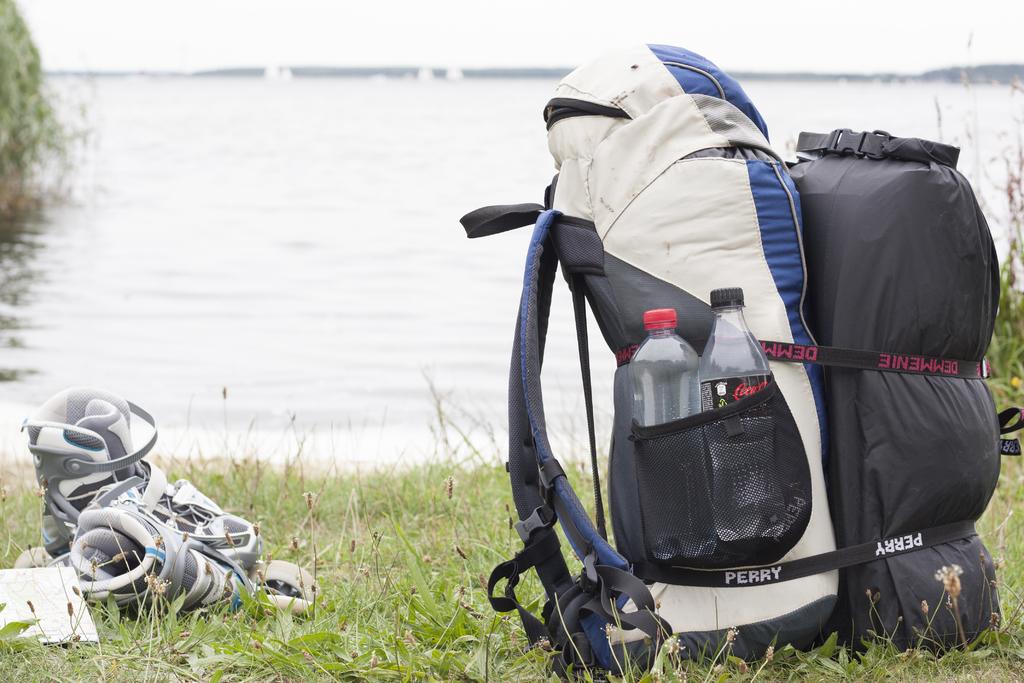What brand of soda is in the side compartment of the backpack?
Offer a terse response. Coca cola. What is written on the strap on the backpack?
Keep it short and to the point. Perry. 